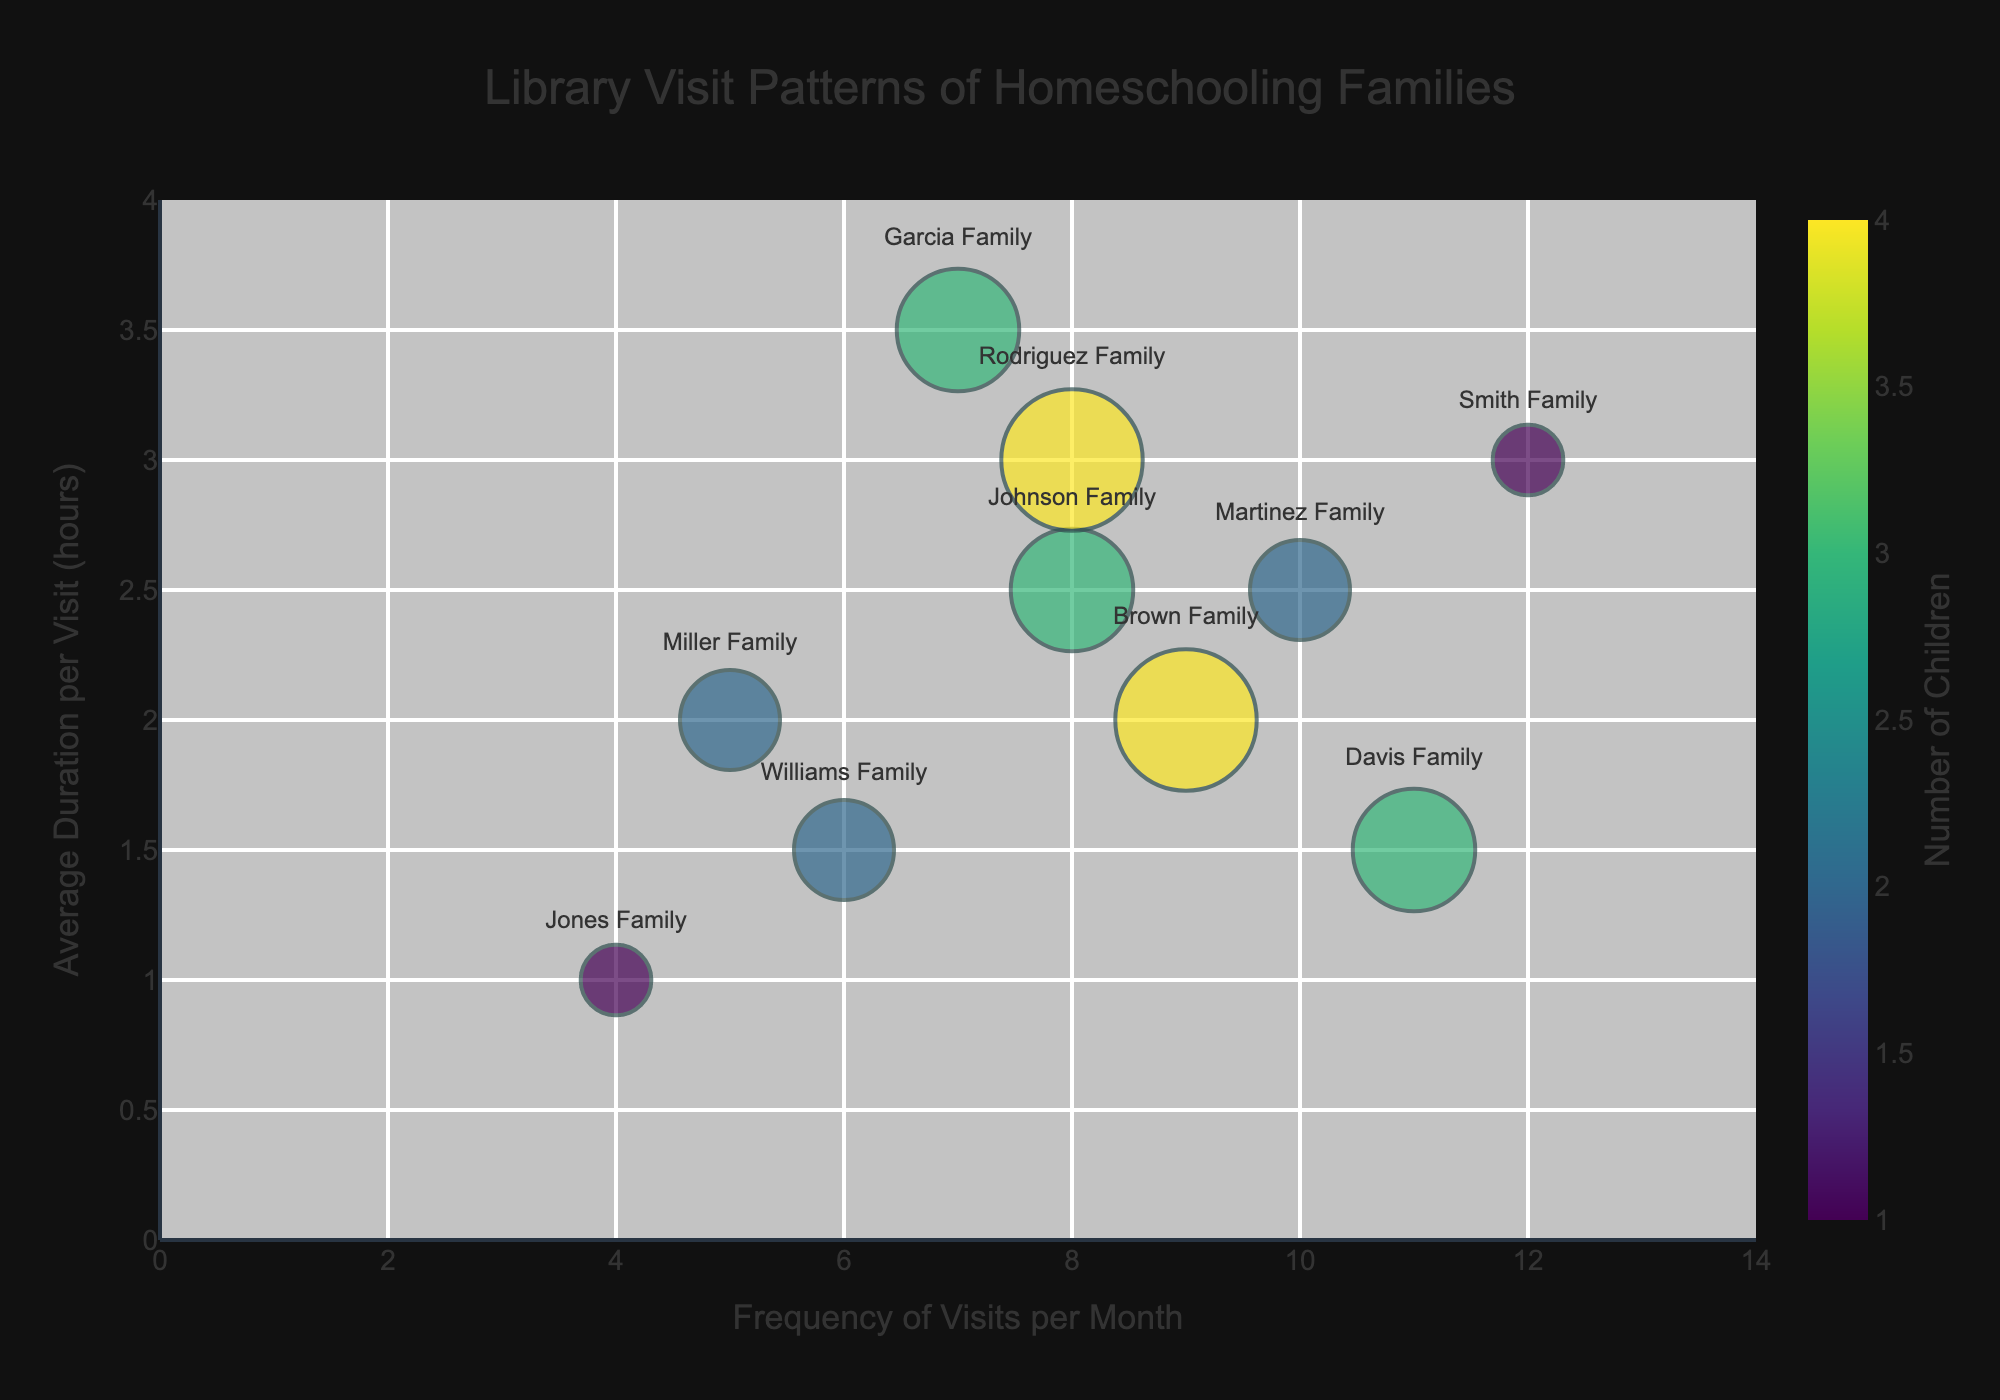what are the axis titles? The x-axis represents the "Frequency of Visits per Month," and the y-axis represents the "Average Duration per Visit (hours)" as indicated by their respective labels.
Answer: Frequency of Visits per Month; Average Duration per Visit (hours) How many families visit the library 8 times per month? By looking at the data points along the x-axis at "8," we see that the Johnson Family and the Rodriguez Family visit the library 8 times a month.
Answer: 2 Which family spends the longest average duration per visit? By examining the y-axis, we see that the Garcia Family has the highest "Average Duration per Visit" at 3.5 hours.
Answer: Garcia Family Which family visits the library most frequently each month? By examining the data points along the x-axis, the Smith Family visits the library the most frequently at 12 times per month.
Answer: Smith Family How many families have 4 children? By looking at the bubble sizes and the color intensity, the Brown Family and the Rodriguez Family each have 4 children.
Answer: 2 What's the difference in visit frequency between the Smith Family and the Jones Family? The Smith Family visits 12 times per month while the Jones Family visits 4 times per month. The difference is 12 - 4 = 8.
Answer: 8 Which family with 3 children spends the least average duration per visit? Out of the Johnson Family, Garcia Family, and Davis Family, who each have 3 children, the Davis Family spends the least average duration per visit at 1.5 hours.
Answer: Davis Family Which two families have the same visit frequency and how often do they visit the library? The Johnson Family and the Rodriguez Family both visit the library 8 times per month.
Answer: Johnson Family; Rodriguez Family; 8 What is the combined number of children for the families that visit the library 10 times per month? The Martinez Family visits the library 10 times per month and they have 2 children. The combined number of children is 2.
Answer: 2 Comparing the Brown Family and the Williams Family, which has more children, and how does their average duration per visit differ? The Brown Family has 4 children while the Williams Family has 2. The Brown Family's average visit duration is 2 hours, whereas the Williams Family's is 1.5 hours; the difference is 2 - 1.5 = 0.5 hours.
Answer: Brown Family; 0.5 hours 